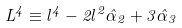Convert formula to latex. <formula><loc_0><loc_0><loc_500><loc_500>L ^ { 4 } \equiv l ^ { 4 } - 2 l ^ { 2 } \hat { \alpha } _ { 2 } + 3 \hat { \alpha } _ { 3 }</formula> 